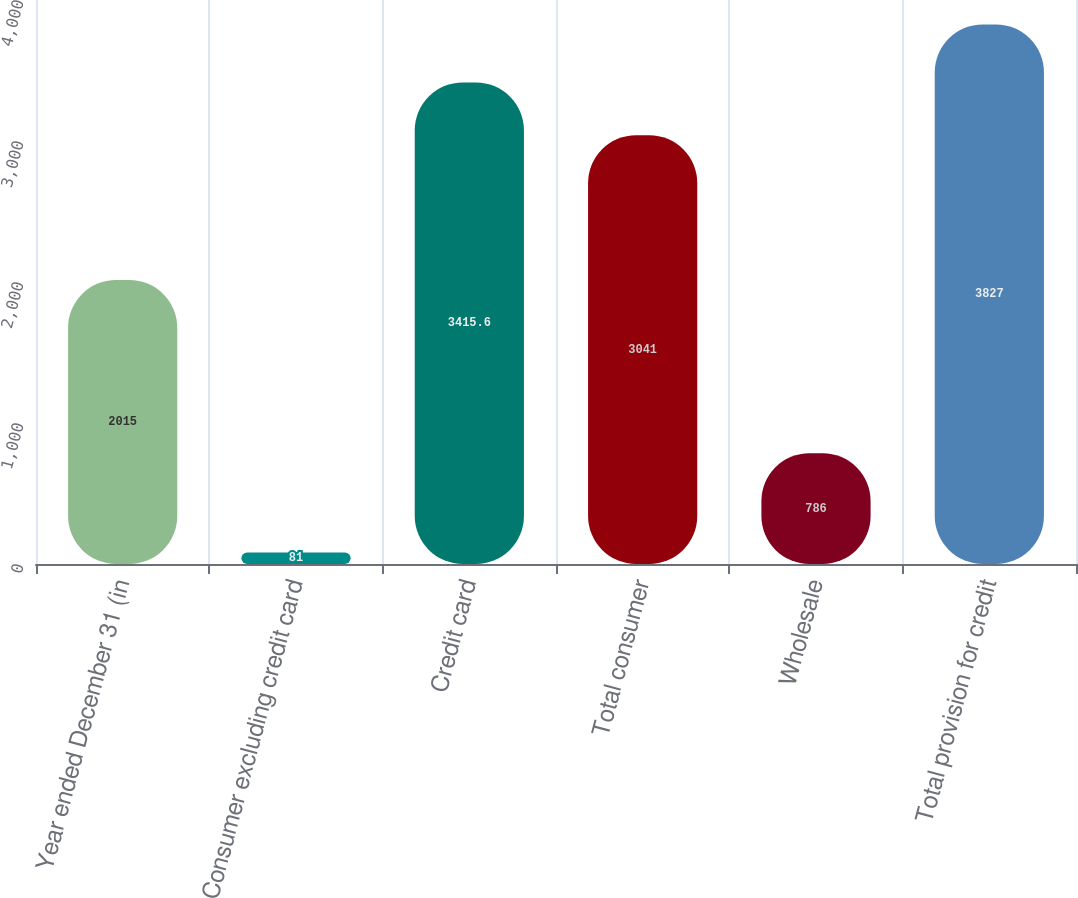<chart> <loc_0><loc_0><loc_500><loc_500><bar_chart><fcel>Year ended December 31 (in<fcel>Consumer excluding credit card<fcel>Credit card<fcel>Total consumer<fcel>Wholesale<fcel>Total provision for credit<nl><fcel>2015<fcel>81<fcel>3415.6<fcel>3041<fcel>786<fcel>3827<nl></chart> 